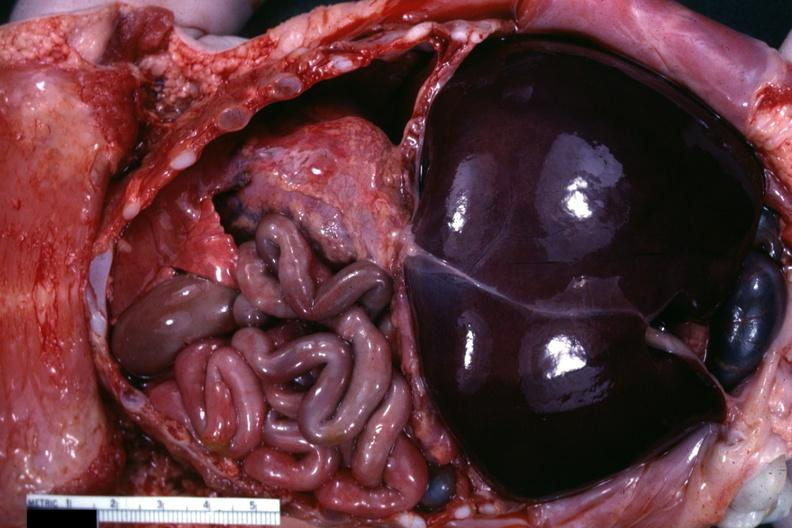does this image show opened body typical?
Answer the question using a single word or phrase. Yes 